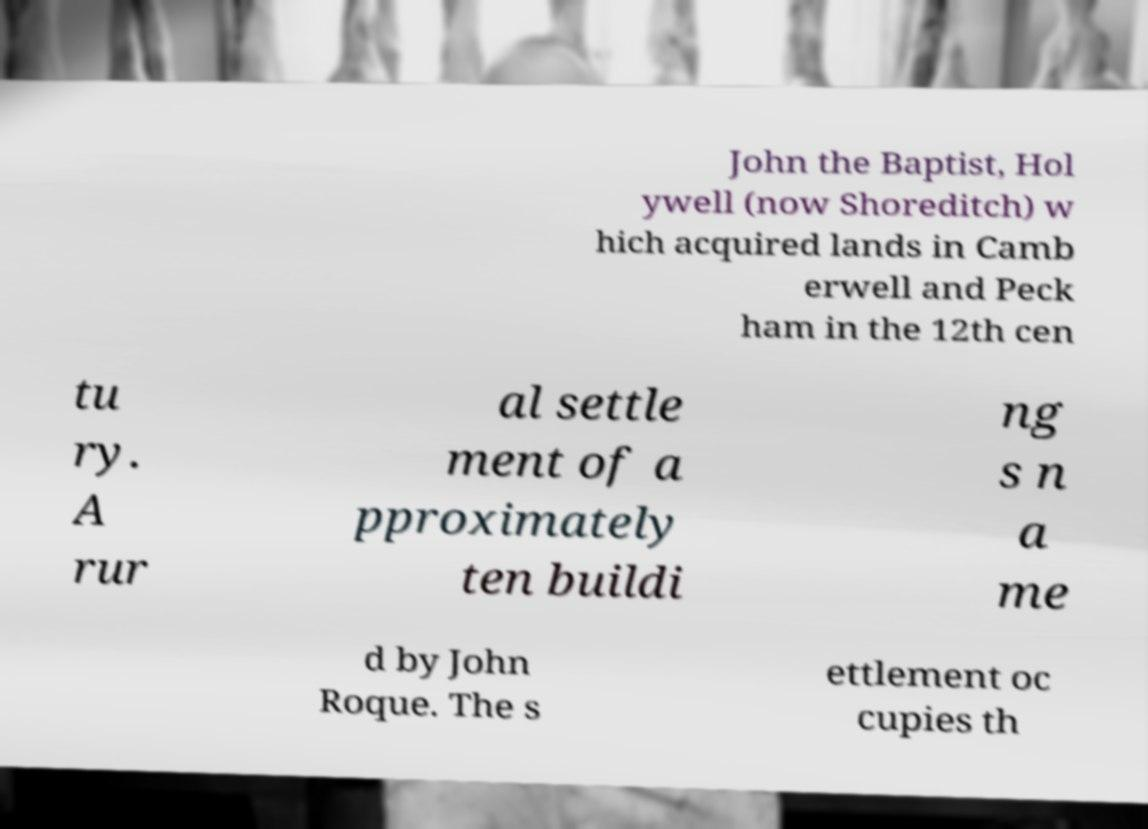Could you extract and type out the text from this image? John the Baptist, Hol ywell (now Shoreditch) w hich acquired lands in Camb erwell and Peck ham in the 12th cen tu ry. A rur al settle ment of a pproximately ten buildi ng s n a me d by John Roque. The s ettlement oc cupies th 